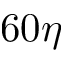<formula> <loc_0><loc_0><loc_500><loc_500>6 0 \eta</formula> 